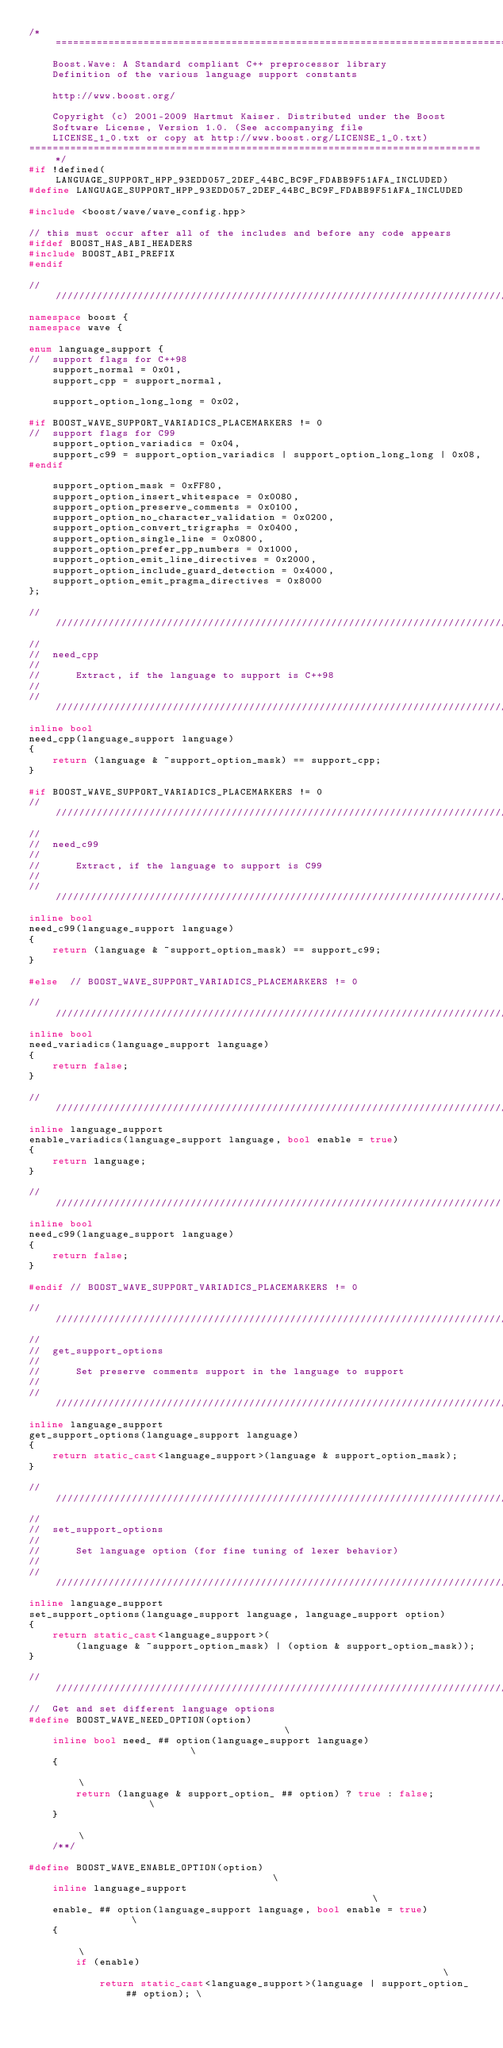<code> <loc_0><loc_0><loc_500><loc_500><_C++_>/*=============================================================================
    Boost.Wave: A Standard compliant C++ preprocessor library
    Definition of the various language support constants
    
    http://www.boost.org/

    Copyright (c) 2001-2009 Hartmut Kaiser. Distributed under the Boost
    Software License, Version 1.0. (See accompanying file
    LICENSE_1_0.txt or copy at http://www.boost.org/LICENSE_1_0.txt)
=============================================================================*/
#if !defined(LANGUAGE_SUPPORT_HPP_93EDD057_2DEF_44BC_BC9F_FDABB9F51AFA_INCLUDED)
#define LANGUAGE_SUPPORT_HPP_93EDD057_2DEF_44BC_BC9F_FDABB9F51AFA_INCLUDED

#include <boost/wave/wave_config.hpp>

// this must occur after all of the includes and before any code appears
#ifdef BOOST_HAS_ABI_HEADERS
#include BOOST_ABI_PREFIX
#endif

///////////////////////////////////////////////////////////////////////////////
namespace boost {
namespace wave {

enum language_support {
//  support flags for C++98
    support_normal = 0x01,
    support_cpp = support_normal,
    
    support_option_long_long = 0x02,

#if BOOST_WAVE_SUPPORT_VARIADICS_PLACEMARKERS != 0
//  support flags for C99
    support_option_variadics = 0x04,
    support_c99 = support_option_variadics | support_option_long_long | 0x08,
#endif 

    support_option_mask = 0xFF80,
    support_option_insert_whitespace = 0x0080,
    support_option_preserve_comments = 0x0100,
    support_option_no_character_validation = 0x0200,
    support_option_convert_trigraphs = 0x0400,
    support_option_single_line = 0x0800,
    support_option_prefer_pp_numbers = 0x1000,
    support_option_emit_line_directives = 0x2000,
    support_option_include_guard_detection = 0x4000,
    support_option_emit_pragma_directives = 0x8000
};

///////////////////////////////////////////////////////////////////////////////
//  
//  need_cpp
//
//      Extract, if the language to support is C++98
//
///////////////////////////////////////////////////////////////////////////////
inline bool
need_cpp(language_support language) 
{
    return (language & ~support_option_mask) == support_cpp;
}

#if BOOST_WAVE_SUPPORT_VARIADICS_PLACEMARKERS != 0
///////////////////////////////////////////////////////////////////////////////
//  
//  need_c99
//
//      Extract, if the language to support is C99
//
///////////////////////////////////////////////////////////////////////////////
inline bool
need_c99(language_support language) 
{
    return (language & ~support_option_mask) == support_c99;
}

#else  // BOOST_WAVE_SUPPORT_VARIADICS_PLACEMARKERS != 0

///////////////////////////////////////////////////////////////////////////////
inline bool 
need_variadics(language_support language) 
{
    return false;
}

///////////////////////////////////////////////////////////////////////////////
inline language_support
enable_variadics(language_support language, bool enable = true)
{
    return language;
}

//////////////////////////////////////////////////////////////////////////////
inline bool
need_c99(language_support language) 
{
    return false;
}

#endif // BOOST_WAVE_SUPPORT_VARIADICS_PLACEMARKERS != 0

///////////////////////////////////////////////////////////////////////////////
//  
//  get_support_options
//
//      Set preserve comments support in the language to support
//
///////////////////////////////////////////////////////////////////////////////
inline language_support
get_support_options(language_support language)
{
    return static_cast<language_support>(language & support_option_mask);
}

///////////////////////////////////////////////////////////////////////////////
//  
//  set_support_options
//
//      Set language option (for fine tuning of lexer behavior)
//
///////////////////////////////////////////////////////////////////////////////
inline language_support
set_support_options(language_support language, language_support option)
{
    return static_cast<language_support>(
        (language & ~support_option_mask) | (option & support_option_mask));
}

///////////////////////////////////////////////////////////////////////////////
//  Get and set different language options
#define BOOST_WAVE_NEED_OPTION(option)                                        \
    inline bool need_ ## option(language_support language)                    \
    {                                                                         \
        return (language & support_option_ ## option) ? true : false;         \
    }                                                                         \
    /**/

#define BOOST_WAVE_ENABLE_OPTION(option)                                      \
    inline language_support                                                   \
    enable_ ## option(language_support language, bool enable = true)          \
    {                                                                         \
        if (enable)                                                           \
            return static_cast<language_support>(language | support_option_ ## option); \</code> 